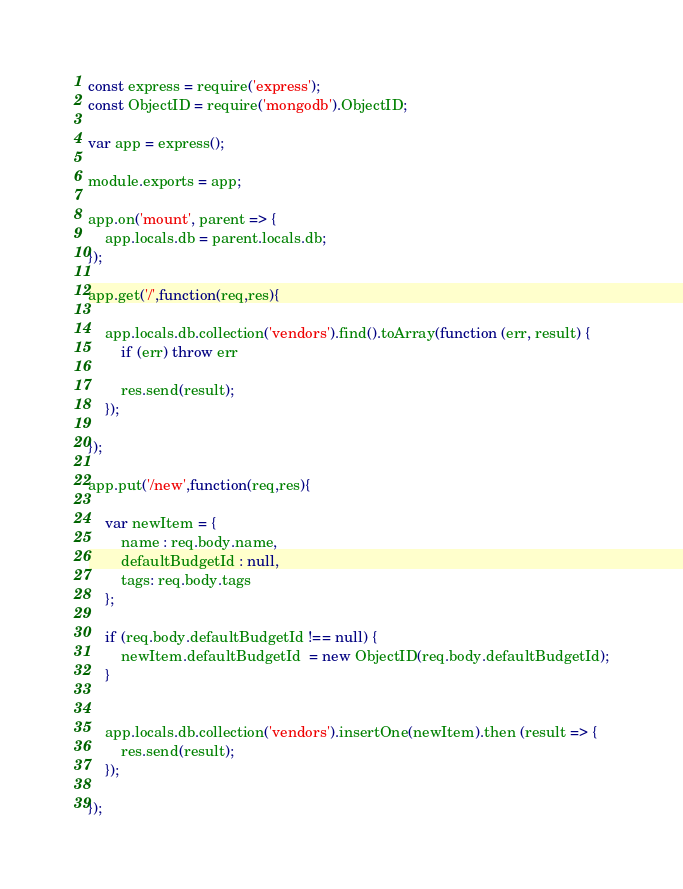<code> <loc_0><loc_0><loc_500><loc_500><_JavaScript_>const express = require('express');
const ObjectID = require('mongodb').ObjectID;

var app = express();

module.exports = app;

app.on('mount', parent => {
    app.locals.db = parent.locals.db;
});

app.get('/',function(req,res){

    app.locals.db.collection('vendors').find().toArray(function (err, result) {
        if (err) throw err

        res.send(result);
    });

});

app.put('/new',function(req,res){

    var newItem = {
        name : req.body.name,
        defaultBudgetId : null,
        tags: req.body.tags
    };

    if (req.body.defaultBudgetId !== null) {
        newItem.defaultBudgetId  = new ObjectID(req.body.defaultBudgetId);
    }
    

    app.locals.db.collection('vendors').insertOne(newItem).then (result => {
        res.send(result);
    });

});</code> 